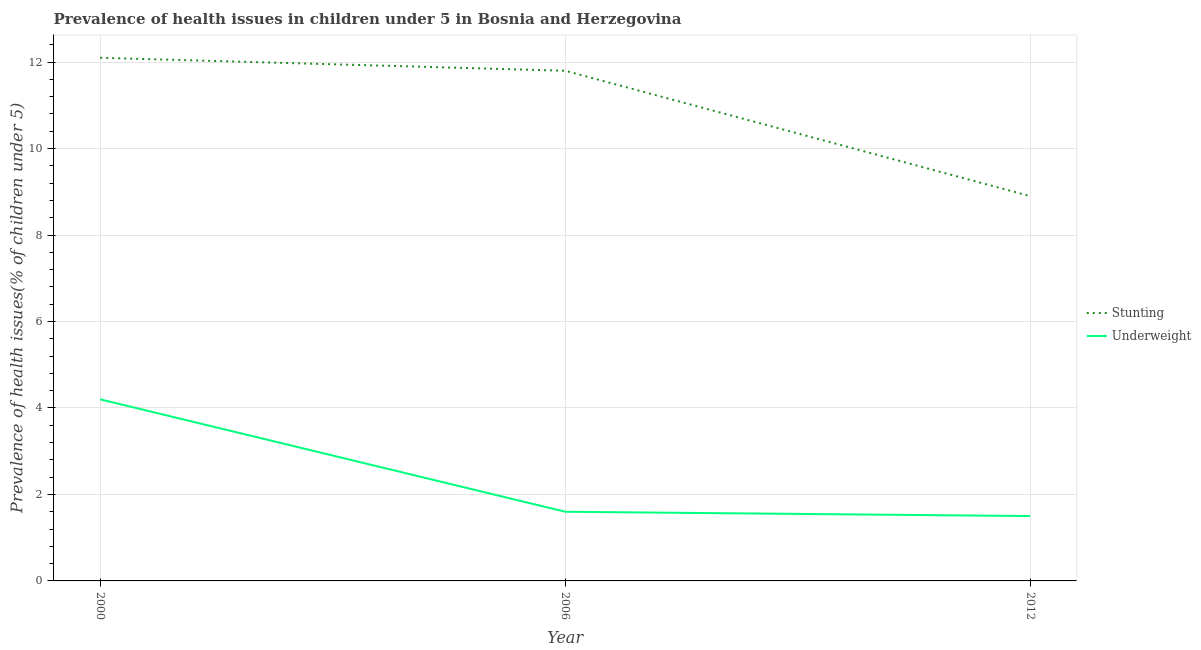What is the percentage of underweight children in 2000?
Provide a short and direct response. 4.2. Across all years, what is the maximum percentage of underweight children?
Ensure brevity in your answer.  4.2. Across all years, what is the minimum percentage of stunted children?
Your response must be concise. 8.9. In which year was the percentage of stunted children maximum?
Provide a short and direct response. 2000. In which year was the percentage of underweight children minimum?
Keep it short and to the point. 2012. What is the total percentage of stunted children in the graph?
Provide a short and direct response. 32.8. What is the difference between the percentage of stunted children in 2000 and that in 2012?
Offer a terse response. 3.2. What is the difference between the percentage of stunted children in 2006 and the percentage of underweight children in 2000?
Your answer should be compact. 7.6. What is the average percentage of stunted children per year?
Your answer should be very brief. 10.93. In the year 2006, what is the difference between the percentage of underweight children and percentage of stunted children?
Ensure brevity in your answer.  -10.2. In how many years, is the percentage of stunted children greater than 6 %?
Your answer should be compact. 3. What is the ratio of the percentage of stunted children in 2000 to that in 2006?
Provide a short and direct response. 1.03. Is the percentage of stunted children in 2006 less than that in 2012?
Provide a short and direct response. No. What is the difference between the highest and the second highest percentage of underweight children?
Provide a short and direct response. 2.6. What is the difference between the highest and the lowest percentage of stunted children?
Give a very brief answer. 3.2. Is the sum of the percentage of underweight children in 2006 and 2012 greater than the maximum percentage of stunted children across all years?
Your response must be concise. No. How many lines are there?
Keep it short and to the point. 2. How many years are there in the graph?
Make the answer very short. 3. What is the difference between two consecutive major ticks on the Y-axis?
Offer a terse response. 2. Are the values on the major ticks of Y-axis written in scientific E-notation?
Offer a very short reply. No. Does the graph contain any zero values?
Make the answer very short. No. What is the title of the graph?
Offer a very short reply. Prevalence of health issues in children under 5 in Bosnia and Herzegovina. What is the label or title of the X-axis?
Offer a very short reply. Year. What is the label or title of the Y-axis?
Offer a very short reply. Prevalence of health issues(% of children under 5). What is the Prevalence of health issues(% of children under 5) in Stunting in 2000?
Provide a succinct answer. 12.1. What is the Prevalence of health issues(% of children under 5) of Underweight in 2000?
Ensure brevity in your answer.  4.2. What is the Prevalence of health issues(% of children under 5) of Stunting in 2006?
Provide a succinct answer. 11.8. What is the Prevalence of health issues(% of children under 5) of Underweight in 2006?
Keep it short and to the point. 1.6. What is the Prevalence of health issues(% of children under 5) in Stunting in 2012?
Offer a terse response. 8.9. Across all years, what is the maximum Prevalence of health issues(% of children under 5) in Stunting?
Your answer should be very brief. 12.1. Across all years, what is the maximum Prevalence of health issues(% of children under 5) in Underweight?
Your response must be concise. 4.2. Across all years, what is the minimum Prevalence of health issues(% of children under 5) of Stunting?
Your answer should be compact. 8.9. What is the total Prevalence of health issues(% of children under 5) of Stunting in the graph?
Keep it short and to the point. 32.8. What is the difference between the Prevalence of health issues(% of children under 5) of Stunting in 2000 and that in 2006?
Your answer should be very brief. 0.3. What is the difference between the Prevalence of health issues(% of children under 5) in Stunting in 2000 and that in 2012?
Make the answer very short. 3.2. What is the difference between the Prevalence of health issues(% of children under 5) of Underweight in 2000 and that in 2012?
Offer a very short reply. 2.7. What is the difference between the Prevalence of health issues(% of children under 5) of Stunting in 2006 and that in 2012?
Provide a short and direct response. 2.9. What is the difference between the Prevalence of health issues(% of children under 5) in Stunting in 2006 and the Prevalence of health issues(% of children under 5) in Underweight in 2012?
Offer a terse response. 10.3. What is the average Prevalence of health issues(% of children under 5) of Stunting per year?
Make the answer very short. 10.93. What is the average Prevalence of health issues(% of children under 5) of Underweight per year?
Ensure brevity in your answer.  2.43. In the year 2012, what is the difference between the Prevalence of health issues(% of children under 5) in Stunting and Prevalence of health issues(% of children under 5) in Underweight?
Ensure brevity in your answer.  7.4. What is the ratio of the Prevalence of health issues(% of children under 5) in Stunting in 2000 to that in 2006?
Offer a very short reply. 1.03. What is the ratio of the Prevalence of health issues(% of children under 5) in Underweight in 2000 to that in 2006?
Ensure brevity in your answer.  2.62. What is the ratio of the Prevalence of health issues(% of children under 5) of Stunting in 2000 to that in 2012?
Your answer should be compact. 1.36. What is the ratio of the Prevalence of health issues(% of children under 5) in Underweight in 2000 to that in 2012?
Offer a very short reply. 2.8. What is the ratio of the Prevalence of health issues(% of children under 5) of Stunting in 2006 to that in 2012?
Your answer should be compact. 1.33. What is the ratio of the Prevalence of health issues(% of children under 5) in Underweight in 2006 to that in 2012?
Offer a terse response. 1.07. What is the difference between the highest and the second highest Prevalence of health issues(% of children under 5) in Stunting?
Keep it short and to the point. 0.3. What is the difference between the highest and the lowest Prevalence of health issues(% of children under 5) of Stunting?
Your answer should be compact. 3.2. 